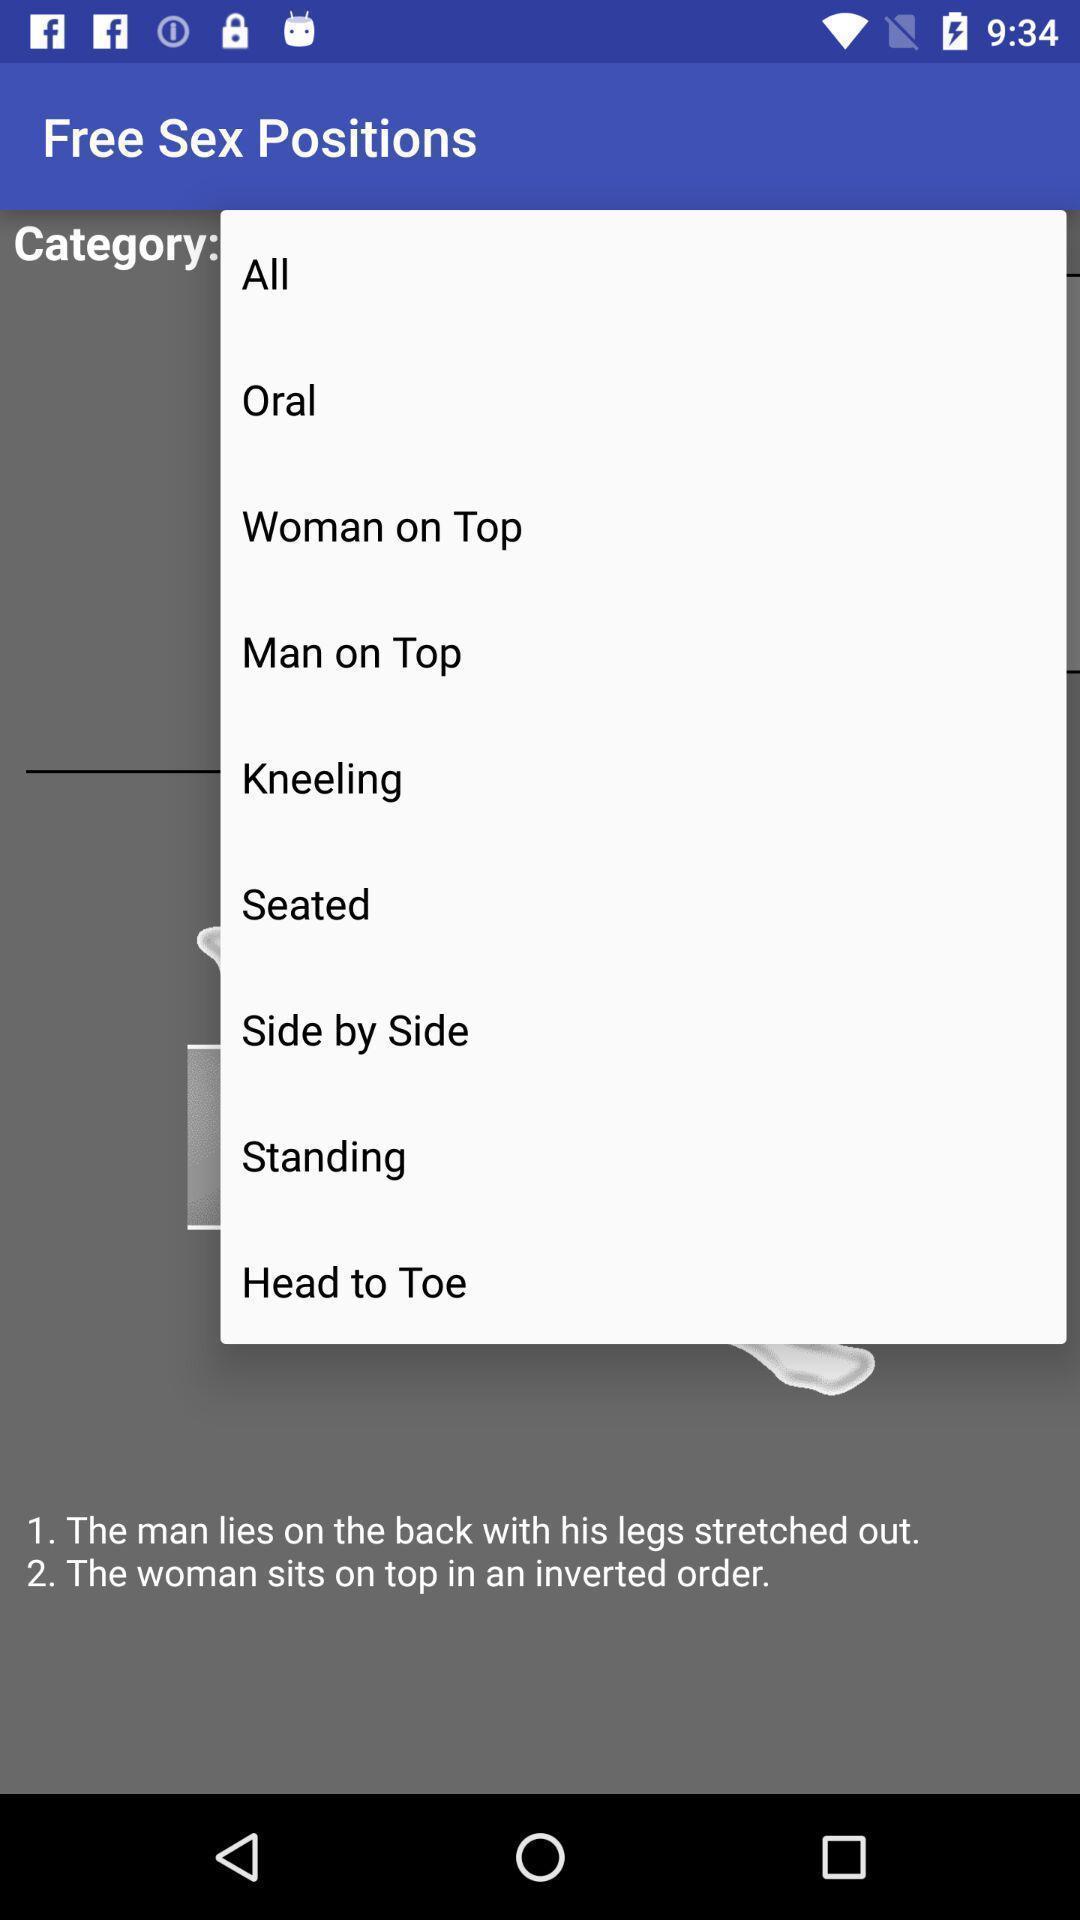Summarize the information in this screenshot. Widget is showing multiple options. 